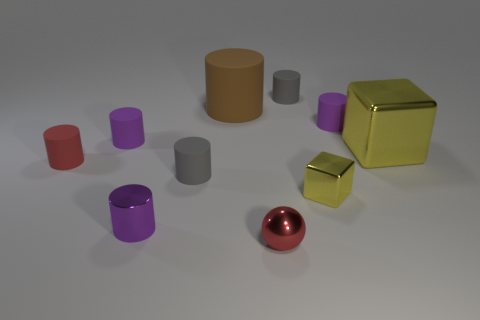Subtract all brown spheres. How many purple cylinders are left? 3 Subtract all red cylinders. How many cylinders are left? 6 Subtract all tiny purple shiny cylinders. How many cylinders are left? 6 Subtract all blue cylinders. Subtract all blue spheres. How many cylinders are left? 7 Subtract all cylinders. How many objects are left? 3 Add 3 gray metal cylinders. How many gray metal cylinders exist? 3 Subtract 0 brown blocks. How many objects are left? 10 Subtract all big yellow metal blocks. Subtract all tiny rubber cylinders. How many objects are left? 4 Add 5 small metallic cubes. How many small metallic cubes are left? 6 